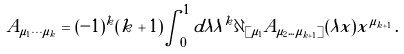<formula> <loc_0><loc_0><loc_500><loc_500>A _ { \mu _ { 1 } \cdots \mu _ { k } } = ( - 1 ) ^ { k } ( k + 1 ) \int _ { 0 } ^ { 1 } d \lambda \lambda ^ { k } \partial _ { [ \mu _ { 1 } } A _ { \mu _ { 2 } \dots \mu _ { k + 1 } ] } ( \lambda x ) x ^ { \mu _ { k + 1 } } \, .</formula> 